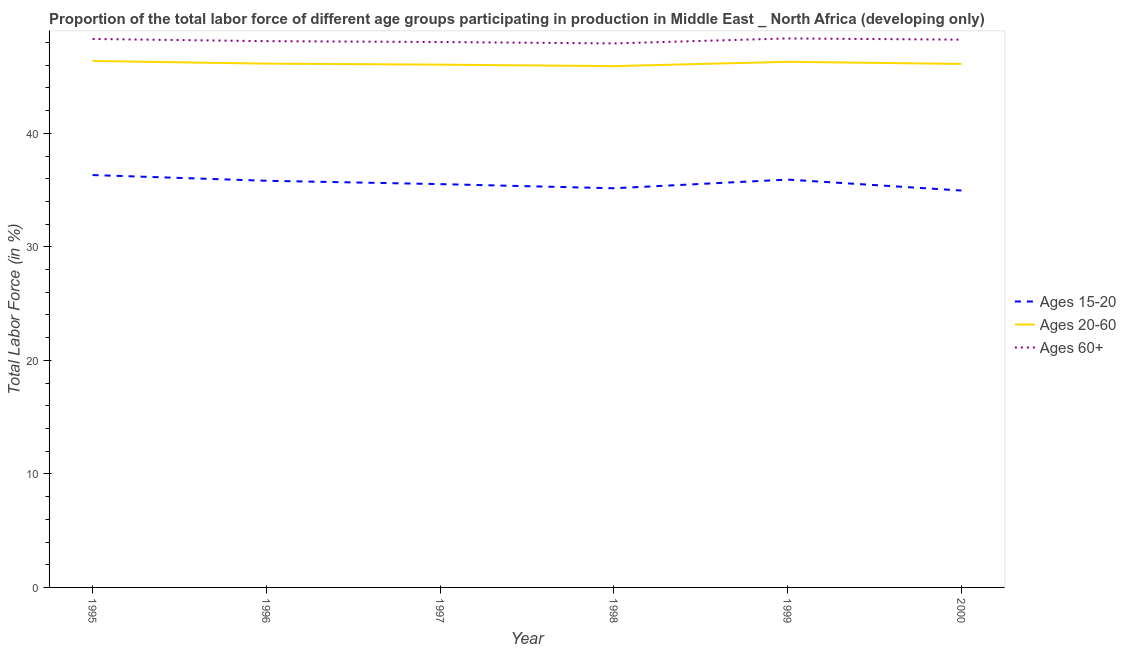Does the line corresponding to percentage of labor force within the age group 15-20 intersect with the line corresponding to percentage of labor force above age 60?
Keep it short and to the point. No. What is the percentage of labor force above age 60 in 1999?
Provide a succinct answer. 48.36. Across all years, what is the maximum percentage of labor force above age 60?
Give a very brief answer. 48.36. Across all years, what is the minimum percentage of labor force within the age group 15-20?
Make the answer very short. 34.96. In which year was the percentage of labor force above age 60 maximum?
Your response must be concise. 1999. What is the total percentage of labor force within the age group 20-60 in the graph?
Offer a terse response. 276.88. What is the difference between the percentage of labor force within the age group 20-60 in 1996 and that in 1999?
Provide a short and direct response. -0.16. What is the difference between the percentage of labor force within the age group 20-60 in 1997 and the percentage of labor force within the age group 15-20 in 1996?
Offer a very short reply. 10.23. What is the average percentage of labor force above age 60 per year?
Your answer should be compact. 48.17. In the year 1996, what is the difference between the percentage of labor force within the age group 20-60 and percentage of labor force within the age group 15-20?
Keep it short and to the point. 10.32. In how many years, is the percentage of labor force within the age group 20-60 greater than 4 %?
Make the answer very short. 6. What is the ratio of the percentage of labor force within the age group 15-20 in 1995 to that in 1998?
Your answer should be compact. 1.03. Is the percentage of labor force above age 60 in 1997 less than that in 2000?
Your answer should be very brief. Yes. Is the difference between the percentage of labor force within the age group 20-60 in 1997 and 1998 greater than the difference between the percentage of labor force above age 60 in 1997 and 1998?
Offer a very short reply. Yes. What is the difference between the highest and the second highest percentage of labor force above age 60?
Give a very brief answer. 0.05. What is the difference between the highest and the lowest percentage of labor force within the age group 15-20?
Your answer should be compact. 1.36. Is the sum of the percentage of labor force within the age group 20-60 in 1998 and 1999 greater than the maximum percentage of labor force above age 60 across all years?
Give a very brief answer. Yes. Is it the case that in every year, the sum of the percentage of labor force within the age group 15-20 and percentage of labor force within the age group 20-60 is greater than the percentage of labor force above age 60?
Your answer should be compact. Yes. Does the percentage of labor force above age 60 monotonically increase over the years?
Your answer should be compact. No. How many years are there in the graph?
Your answer should be compact. 6. What is the difference between two consecutive major ticks on the Y-axis?
Give a very brief answer. 10. Does the graph contain any zero values?
Provide a short and direct response. No. How many legend labels are there?
Ensure brevity in your answer.  3. How are the legend labels stacked?
Your answer should be very brief. Vertical. What is the title of the graph?
Your response must be concise. Proportion of the total labor force of different age groups participating in production in Middle East _ North Africa (developing only). Does "Poland" appear as one of the legend labels in the graph?
Make the answer very short. No. What is the Total Labor Force (in %) in Ages 15-20 in 1995?
Give a very brief answer. 36.32. What is the Total Labor Force (in %) of Ages 20-60 in 1995?
Your response must be concise. 46.37. What is the Total Labor Force (in %) in Ages 60+ in 1995?
Offer a very short reply. 48.31. What is the Total Labor Force (in %) of Ages 15-20 in 1996?
Give a very brief answer. 35.82. What is the Total Labor Force (in %) in Ages 20-60 in 1996?
Keep it short and to the point. 46.14. What is the Total Labor Force (in %) in Ages 60+ in 1996?
Provide a short and direct response. 48.12. What is the Total Labor Force (in %) of Ages 15-20 in 1997?
Offer a very short reply. 35.52. What is the Total Labor Force (in %) in Ages 20-60 in 1997?
Offer a terse response. 46.05. What is the Total Labor Force (in %) in Ages 60+ in 1997?
Provide a short and direct response. 48.04. What is the Total Labor Force (in %) in Ages 15-20 in 1998?
Provide a short and direct response. 35.16. What is the Total Labor Force (in %) of Ages 20-60 in 1998?
Offer a very short reply. 45.92. What is the Total Labor Force (in %) in Ages 60+ in 1998?
Your answer should be very brief. 47.92. What is the Total Labor Force (in %) of Ages 15-20 in 1999?
Offer a terse response. 35.92. What is the Total Labor Force (in %) of Ages 20-60 in 1999?
Make the answer very short. 46.3. What is the Total Labor Force (in %) of Ages 60+ in 1999?
Offer a very short reply. 48.36. What is the Total Labor Force (in %) in Ages 15-20 in 2000?
Offer a very short reply. 34.96. What is the Total Labor Force (in %) of Ages 20-60 in 2000?
Your answer should be compact. 46.11. What is the Total Labor Force (in %) of Ages 60+ in 2000?
Give a very brief answer. 48.25. Across all years, what is the maximum Total Labor Force (in %) in Ages 15-20?
Your answer should be compact. 36.32. Across all years, what is the maximum Total Labor Force (in %) of Ages 20-60?
Provide a short and direct response. 46.37. Across all years, what is the maximum Total Labor Force (in %) of Ages 60+?
Give a very brief answer. 48.36. Across all years, what is the minimum Total Labor Force (in %) of Ages 15-20?
Your answer should be compact. 34.96. Across all years, what is the minimum Total Labor Force (in %) of Ages 20-60?
Keep it short and to the point. 45.92. Across all years, what is the minimum Total Labor Force (in %) of Ages 60+?
Provide a short and direct response. 47.92. What is the total Total Labor Force (in %) in Ages 15-20 in the graph?
Offer a very short reply. 213.71. What is the total Total Labor Force (in %) in Ages 20-60 in the graph?
Offer a very short reply. 276.88. What is the total Total Labor Force (in %) of Ages 60+ in the graph?
Give a very brief answer. 288.99. What is the difference between the Total Labor Force (in %) in Ages 15-20 in 1995 and that in 1996?
Your answer should be very brief. 0.5. What is the difference between the Total Labor Force (in %) of Ages 20-60 in 1995 and that in 1996?
Ensure brevity in your answer.  0.23. What is the difference between the Total Labor Force (in %) of Ages 60+ in 1995 and that in 1996?
Give a very brief answer. 0.19. What is the difference between the Total Labor Force (in %) in Ages 15-20 in 1995 and that in 1997?
Your answer should be very brief. 0.8. What is the difference between the Total Labor Force (in %) in Ages 20-60 in 1995 and that in 1997?
Your response must be concise. 0.32. What is the difference between the Total Labor Force (in %) of Ages 60+ in 1995 and that in 1997?
Give a very brief answer. 0.27. What is the difference between the Total Labor Force (in %) of Ages 15-20 in 1995 and that in 1998?
Your answer should be compact. 1.16. What is the difference between the Total Labor Force (in %) in Ages 20-60 in 1995 and that in 1998?
Offer a terse response. 0.45. What is the difference between the Total Labor Force (in %) in Ages 60+ in 1995 and that in 1998?
Ensure brevity in your answer.  0.39. What is the difference between the Total Labor Force (in %) of Ages 15-20 in 1995 and that in 1999?
Offer a terse response. 0.4. What is the difference between the Total Labor Force (in %) of Ages 20-60 in 1995 and that in 1999?
Your response must be concise. 0.07. What is the difference between the Total Labor Force (in %) in Ages 60+ in 1995 and that in 1999?
Your answer should be very brief. -0.05. What is the difference between the Total Labor Force (in %) in Ages 15-20 in 1995 and that in 2000?
Offer a terse response. 1.36. What is the difference between the Total Labor Force (in %) of Ages 20-60 in 1995 and that in 2000?
Give a very brief answer. 0.26. What is the difference between the Total Labor Force (in %) of Ages 60+ in 1995 and that in 2000?
Your answer should be very brief. 0.06. What is the difference between the Total Labor Force (in %) of Ages 15-20 in 1996 and that in 1997?
Give a very brief answer. 0.3. What is the difference between the Total Labor Force (in %) of Ages 20-60 in 1996 and that in 1997?
Ensure brevity in your answer.  0.09. What is the difference between the Total Labor Force (in %) of Ages 60+ in 1996 and that in 1997?
Offer a terse response. 0.08. What is the difference between the Total Labor Force (in %) in Ages 15-20 in 1996 and that in 1998?
Give a very brief answer. 0.66. What is the difference between the Total Labor Force (in %) of Ages 20-60 in 1996 and that in 1998?
Your answer should be compact. 0.22. What is the difference between the Total Labor Force (in %) of Ages 60+ in 1996 and that in 1998?
Provide a succinct answer. 0.2. What is the difference between the Total Labor Force (in %) of Ages 15-20 in 1996 and that in 1999?
Make the answer very short. -0.1. What is the difference between the Total Labor Force (in %) of Ages 20-60 in 1996 and that in 1999?
Give a very brief answer. -0.16. What is the difference between the Total Labor Force (in %) of Ages 60+ in 1996 and that in 1999?
Your response must be concise. -0.24. What is the difference between the Total Labor Force (in %) in Ages 15-20 in 1996 and that in 2000?
Ensure brevity in your answer.  0.86. What is the difference between the Total Labor Force (in %) in Ages 20-60 in 1996 and that in 2000?
Provide a succinct answer. 0.03. What is the difference between the Total Labor Force (in %) in Ages 60+ in 1996 and that in 2000?
Offer a very short reply. -0.13. What is the difference between the Total Labor Force (in %) of Ages 15-20 in 1997 and that in 1998?
Give a very brief answer. 0.37. What is the difference between the Total Labor Force (in %) in Ages 20-60 in 1997 and that in 1998?
Provide a short and direct response. 0.13. What is the difference between the Total Labor Force (in %) of Ages 60+ in 1997 and that in 1998?
Provide a short and direct response. 0.12. What is the difference between the Total Labor Force (in %) of Ages 15-20 in 1997 and that in 1999?
Your answer should be compact. -0.4. What is the difference between the Total Labor Force (in %) in Ages 20-60 in 1997 and that in 1999?
Give a very brief answer. -0.25. What is the difference between the Total Labor Force (in %) in Ages 60+ in 1997 and that in 1999?
Your answer should be very brief. -0.32. What is the difference between the Total Labor Force (in %) of Ages 15-20 in 1997 and that in 2000?
Your answer should be very brief. 0.57. What is the difference between the Total Labor Force (in %) in Ages 20-60 in 1997 and that in 2000?
Ensure brevity in your answer.  -0.07. What is the difference between the Total Labor Force (in %) in Ages 60+ in 1997 and that in 2000?
Give a very brief answer. -0.21. What is the difference between the Total Labor Force (in %) of Ages 15-20 in 1998 and that in 1999?
Your answer should be very brief. -0.76. What is the difference between the Total Labor Force (in %) in Ages 20-60 in 1998 and that in 1999?
Your answer should be very brief. -0.38. What is the difference between the Total Labor Force (in %) of Ages 60+ in 1998 and that in 1999?
Make the answer very short. -0.44. What is the difference between the Total Labor Force (in %) in Ages 15-20 in 1998 and that in 2000?
Make the answer very short. 0.2. What is the difference between the Total Labor Force (in %) of Ages 20-60 in 1998 and that in 2000?
Ensure brevity in your answer.  -0.19. What is the difference between the Total Labor Force (in %) of Ages 60+ in 1998 and that in 2000?
Make the answer very short. -0.33. What is the difference between the Total Labor Force (in %) in Ages 15-20 in 1999 and that in 2000?
Keep it short and to the point. 0.96. What is the difference between the Total Labor Force (in %) in Ages 20-60 in 1999 and that in 2000?
Give a very brief answer. 0.19. What is the difference between the Total Labor Force (in %) in Ages 60+ in 1999 and that in 2000?
Offer a terse response. 0.11. What is the difference between the Total Labor Force (in %) of Ages 15-20 in 1995 and the Total Labor Force (in %) of Ages 20-60 in 1996?
Provide a short and direct response. -9.81. What is the difference between the Total Labor Force (in %) of Ages 15-20 in 1995 and the Total Labor Force (in %) of Ages 60+ in 1996?
Keep it short and to the point. -11.79. What is the difference between the Total Labor Force (in %) of Ages 20-60 in 1995 and the Total Labor Force (in %) of Ages 60+ in 1996?
Offer a terse response. -1.75. What is the difference between the Total Labor Force (in %) in Ages 15-20 in 1995 and the Total Labor Force (in %) in Ages 20-60 in 1997?
Offer a terse response. -9.72. What is the difference between the Total Labor Force (in %) of Ages 15-20 in 1995 and the Total Labor Force (in %) of Ages 60+ in 1997?
Keep it short and to the point. -11.72. What is the difference between the Total Labor Force (in %) of Ages 20-60 in 1995 and the Total Labor Force (in %) of Ages 60+ in 1997?
Keep it short and to the point. -1.67. What is the difference between the Total Labor Force (in %) of Ages 15-20 in 1995 and the Total Labor Force (in %) of Ages 20-60 in 1998?
Make the answer very short. -9.6. What is the difference between the Total Labor Force (in %) in Ages 15-20 in 1995 and the Total Labor Force (in %) in Ages 60+ in 1998?
Keep it short and to the point. -11.59. What is the difference between the Total Labor Force (in %) in Ages 20-60 in 1995 and the Total Labor Force (in %) in Ages 60+ in 1998?
Your answer should be very brief. -1.55. What is the difference between the Total Labor Force (in %) of Ages 15-20 in 1995 and the Total Labor Force (in %) of Ages 20-60 in 1999?
Your answer should be very brief. -9.98. What is the difference between the Total Labor Force (in %) in Ages 15-20 in 1995 and the Total Labor Force (in %) in Ages 60+ in 1999?
Provide a short and direct response. -12.03. What is the difference between the Total Labor Force (in %) in Ages 20-60 in 1995 and the Total Labor Force (in %) in Ages 60+ in 1999?
Provide a short and direct response. -1.99. What is the difference between the Total Labor Force (in %) in Ages 15-20 in 1995 and the Total Labor Force (in %) in Ages 20-60 in 2000?
Offer a terse response. -9.79. What is the difference between the Total Labor Force (in %) in Ages 15-20 in 1995 and the Total Labor Force (in %) in Ages 60+ in 2000?
Your answer should be very brief. -11.93. What is the difference between the Total Labor Force (in %) of Ages 20-60 in 1995 and the Total Labor Force (in %) of Ages 60+ in 2000?
Offer a terse response. -1.88. What is the difference between the Total Labor Force (in %) of Ages 15-20 in 1996 and the Total Labor Force (in %) of Ages 20-60 in 1997?
Keep it short and to the point. -10.23. What is the difference between the Total Labor Force (in %) in Ages 15-20 in 1996 and the Total Labor Force (in %) in Ages 60+ in 1997?
Ensure brevity in your answer.  -12.22. What is the difference between the Total Labor Force (in %) of Ages 20-60 in 1996 and the Total Labor Force (in %) of Ages 60+ in 1997?
Provide a short and direct response. -1.9. What is the difference between the Total Labor Force (in %) in Ages 15-20 in 1996 and the Total Labor Force (in %) in Ages 20-60 in 1998?
Make the answer very short. -10.1. What is the difference between the Total Labor Force (in %) in Ages 15-20 in 1996 and the Total Labor Force (in %) in Ages 60+ in 1998?
Provide a succinct answer. -12.1. What is the difference between the Total Labor Force (in %) in Ages 20-60 in 1996 and the Total Labor Force (in %) in Ages 60+ in 1998?
Provide a succinct answer. -1.78. What is the difference between the Total Labor Force (in %) in Ages 15-20 in 1996 and the Total Labor Force (in %) in Ages 20-60 in 1999?
Your response must be concise. -10.48. What is the difference between the Total Labor Force (in %) of Ages 15-20 in 1996 and the Total Labor Force (in %) of Ages 60+ in 1999?
Your answer should be compact. -12.54. What is the difference between the Total Labor Force (in %) of Ages 20-60 in 1996 and the Total Labor Force (in %) of Ages 60+ in 1999?
Offer a terse response. -2.22. What is the difference between the Total Labor Force (in %) of Ages 15-20 in 1996 and the Total Labor Force (in %) of Ages 20-60 in 2000?
Offer a terse response. -10.29. What is the difference between the Total Labor Force (in %) in Ages 15-20 in 1996 and the Total Labor Force (in %) in Ages 60+ in 2000?
Provide a succinct answer. -12.43. What is the difference between the Total Labor Force (in %) of Ages 20-60 in 1996 and the Total Labor Force (in %) of Ages 60+ in 2000?
Provide a short and direct response. -2.11. What is the difference between the Total Labor Force (in %) of Ages 15-20 in 1997 and the Total Labor Force (in %) of Ages 20-60 in 1998?
Keep it short and to the point. -10.39. What is the difference between the Total Labor Force (in %) in Ages 15-20 in 1997 and the Total Labor Force (in %) in Ages 60+ in 1998?
Your answer should be very brief. -12.39. What is the difference between the Total Labor Force (in %) in Ages 20-60 in 1997 and the Total Labor Force (in %) in Ages 60+ in 1998?
Make the answer very short. -1.87. What is the difference between the Total Labor Force (in %) in Ages 15-20 in 1997 and the Total Labor Force (in %) in Ages 20-60 in 1999?
Ensure brevity in your answer.  -10.77. What is the difference between the Total Labor Force (in %) in Ages 15-20 in 1997 and the Total Labor Force (in %) in Ages 60+ in 1999?
Give a very brief answer. -12.83. What is the difference between the Total Labor Force (in %) of Ages 20-60 in 1997 and the Total Labor Force (in %) of Ages 60+ in 1999?
Offer a very short reply. -2.31. What is the difference between the Total Labor Force (in %) of Ages 15-20 in 1997 and the Total Labor Force (in %) of Ages 20-60 in 2000?
Provide a succinct answer. -10.59. What is the difference between the Total Labor Force (in %) in Ages 15-20 in 1997 and the Total Labor Force (in %) in Ages 60+ in 2000?
Keep it short and to the point. -12.73. What is the difference between the Total Labor Force (in %) in Ages 20-60 in 1997 and the Total Labor Force (in %) in Ages 60+ in 2000?
Your answer should be very brief. -2.2. What is the difference between the Total Labor Force (in %) of Ages 15-20 in 1998 and the Total Labor Force (in %) of Ages 20-60 in 1999?
Your answer should be compact. -11.14. What is the difference between the Total Labor Force (in %) of Ages 15-20 in 1998 and the Total Labor Force (in %) of Ages 60+ in 1999?
Your response must be concise. -13.2. What is the difference between the Total Labor Force (in %) of Ages 20-60 in 1998 and the Total Labor Force (in %) of Ages 60+ in 1999?
Your response must be concise. -2.44. What is the difference between the Total Labor Force (in %) of Ages 15-20 in 1998 and the Total Labor Force (in %) of Ages 20-60 in 2000?
Make the answer very short. -10.95. What is the difference between the Total Labor Force (in %) in Ages 15-20 in 1998 and the Total Labor Force (in %) in Ages 60+ in 2000?
Give a very brief answer. -13.09. What is the difference between the Total Labor Force (in %) of Ages 20-60 in 1998 and the Total Labor Force (in %) of Ages 60+ in 2000?
Ensure brevity in your answer.  -2.33. What is the difference between the Total Labor Force (in %) in Ages 15-20 in 1999 and the Total Labor Force (in %) in Ages 20-60 in 2000?
Your answer should be very brief. -10.19. What is the difference between the Total Labor Force (in %) in Ages 15-20 in 1999 and the Total Labor Force (in %) in Ages 60+ in 2000?
Your answer should be compact. -12.33. What is the difference between the Total Labor Force (in %) in Ages 20-60 in 1999 and the Total Labor Force (in %) in Ages 60+ in 2000?
Provide a short and direct response. -1.95. What is the average Total Labor Force (in %) of Ages 15-20 per year?
Your answer should be compact. 35.62. What is the average Total Labor Force (in %) of Ages 20-60 per year?
Offer a terse response. 46.15. What is the average Total Labor Force (in %) in Ages 60+ per year?
Offer a terse response. 48.16. In the year 1995, what is the difference between the Total Labor Force (in %) in Ages 15-20 and Total Labor Force (in %) in Ages 20-60?
Your answer should be very brief. -10.05. In the year 1995, what is the difference between the Total Labor Force (in %) of Ages 15-20 and Total Labor Force (in %) of Ages 60+?
Your answer should be compact. -11.99. In the year 1995, what is the difference between the Total Labor Force (in %) of Ages 20-60 and Total Labor Force (in %) of Ages 60+?
Ensure brevity in your answer.  -1.94. In the year 1996, what is the difference between the Total Labor Force (in %) in Ages 15-20 and Total Labor Force (in %) in Ages 20-60?
Your answer should be compact. -10.32. In the year 1996, what is the difference between the Total Labor Force (in %) of Ages 15-20 and Total Labor Force (in %) of Ages 60+?
Your answer should be very brief. -12.3. In the year 1996, what is the difference between the Total Labor Force (in %) of Ages 20-60 and Total Labor Force (in %) of Ages 60+?
Your answer should be very brief. -1.98. In the year 1997, what is the difference between the Total Labor Force (in %) of Ages 15-20 and Total Labor Force (in %) of Ages 20-60?
Make the answer very short. -10.52. In the year 1997, what is the difference between the Total Labor Force (in %) of Ages 15-20 and Total Labor Force (in %) of Ages 60+?
Your response must be concise. -12.52. In the year 1997, what is the difference between the Total Labor Force (in %) of Ages 20-60 and Total Labor Force (in %) of Ages 60+?
Give a very brief answer. -1.99. In the year 1998, what is the difference between the Total Labor Force (in %) of Ages 15-20 and Total Labor Force (in %) of Ages 20-60?
Provide a succinct answer. -10.76. In the year 1998, what is the difference between the Total Labor Force (in %) of Ages 15-20 and Total Labor Force (in %) of Ages 60+?
Provide a succinct answer. -12.76. In the year 1998, what is the difference between the Total Labor Force (in %) in Ages 20-60 and Total Labor Force (in %) in Ages 60+?
Your response must be concise. -2. In the year 1999, what is the difference between the Total Labor Force (in %) in Ages 15-20 and Total Labor Force (in %) in Ages 20-60?
Your answer should be compact. -10.38. In the year 1999, what is the difference between the Total Labor Force (in %) of Ages 15-20 and Total Labor Force (in %) of Ages 60+?
Give a very brief answer. -12.43. In the year 1999, what is the difference between the Total Labor Force (in %) in Ages 20-60 and Total Labor Force (in %) in Ages 60+?
Offer a terse response. -2.06. In the year 2000, what is the difference between the Total Labor Force (in %) of Ages 15-20 and Total Labor Force (in %) of Ages 20-60?
Give a very brief answer. -11.15. In the year 2000, what is the difference between the Total Labor Force (in %) in Ages 15-20 and Total Labor Force (in %) in Ages 60+?
Ensure brevity in your answer.  -13.29. In the year 2000, what is the difference between the Total Labor Force (in %) of Ages 20-60 and Total Labor Force (in %) of Ages 60+?
Give a very brief answer. -2.14. What is the ratio of the Total Labor Force (in %) of Ages 20-60 in 1995 to that in 1996?
Give a very brief answer. 1.01. What is the ratio of the Total Labor Force (in %) of Ages 15-20 in 1995 to that in 1997?
Your response must be concise. 1.02. What is the ratio of the Total Labor Force (in %) of Ages 60+ in 1995 to that in 1997?
Provide a succinct answer. 1.01. What is the ratio of the Total Labor Force (in %) of Ages 15-20 in 1995 to that in 1998?
Give a very brief answer. 1.03. What is the ratio of the Total Labor Force (in %) of Ages 20-60 in 1995 to that in 1998?
Keep it short and to the point. 1.01. What is the ratio of the Total Labor Force (in %) of Ages 60+ in 1995 to that in 1998?
Your answer should be very brief. 1.01. What is the ratio of the Total Labor Force (in %) of Ages 15-20 in 1995 to that in 1999?
Offer a very short reply. 1.01. What is the ratio of the Total Labor Force (in %) in Ages 20-60 in 1995 to that in 1999?
Make the answer very short. 1. What is the ratio of the Total Labor Force (in %) of Ages 60+ in 1995 to that in 1999?
Keep it short and to the point. 1. What is the ratio of the Total Labor Force (in %) of Ages 15-20 in 1995 to that in 2000?
Give a very brief answer. 1.04. What is the ratio of the Total Labor Force (in %) in Ages 20-60 in 1995 to that in 2000?
Provide a succinct answer. 1.01. What is the ratio of the Total Labor Force (in %) in Ages 15-20 in 1996 to that in 1997?
Your answer should be very brief. 1.01. What is the ratio of the Total Labor Force (in %) of Ages 15-20 in 1996 to that in 1998?
Provide a short and direct response. 1.02. What is the ratio of the Total Labor Force (in %) in Ages 15-20 in 1996 to that in 1999?
Keep it short and to the point. 1. What is the ratio of the Total Labor Force (in %) of Ages 20-60 in 1996 to that in 1999?
Offer a terse response. 1. What is the ratio of the Total Labor Force (in %) of Ages 60+ in 1996 to that in 1999?
Provide a short and direct response. 0.99. What is the ratio of the Total Labor Force (in %) of Ages 15-20 in 1996 to that in 2000?
Ensure brevity in your answer.  1.02. What is the ratio of the Total Labor Force (in %) in Ages 15-20 in 1997 to that in 1998?
Ensure brevity in your answer.  1.01. What is the ratio of the Total Labor Force (in %) in Ages 20-60 in 1997 to that in 1998?
Your response must be concise. 1. What is the ratio of the Total Labor Force (in %) of Ages 15-20 in 1997 to that in 1999?
Your answer should be very brief. 0.99. What is the ratio of the Total Labor Force (in %) in Ages 20-60 in 1997 to that in 1999?
Give a very brief answer. 0.99. What is the ratio of the Total Labor Force (in %) in Ages 60+ in 1997 to that in 1999?
Your answer should be very brief. 0.99. What is the ratio of the Total Labor Force (in %) of Ages 15-20 in 1997 to that in 2000?
Ensure brevity in your answer.  1.02. What is the ratio of the Total Labor Force (in %) in Ages 20-60 in 1997 to that in 2000?
Give a very brief answer. 1. What is the ratio of the Total Labor Force (in %) of Ages 15-20 in 1998 to that in 1999?
Your answer should be compact. 0.98. What is the ratio of the Total Labor Force (in %) in Ages 20-60 in 1998 to that in 1999?
Your response must be concise. 0.99. What is the ratio of the Total Labor Force (in %) in Ages 60+ in 1998 to that in 1999?
Your answer should be very brief. 0.99. What is the ratio of the Total Labor Force (in %) in Ages 15-20 in 1998 to that in 2000?
Provide a short and direct response. 1.01. What is the ratio of the Total Labor Force (in %) of Ages 15-20 in 1999 to that in 2000?
Provide a short and direct response. 1.03. What is the difference between the highest and the second highest Total Labor Force (in %) of Ages 15-20?
Your answer should be compact. 0.4. What is the difference between the highest and the second highest Total Labor Force (in %) of Ages 20-60?
Ensure brevity in your answer.  0.07. What is the difference between the highest and the second highest Total Labor Force (in %) in Ages 60+?
Keep it short and to the point. 0.05. What is the difference between the highest and the lowest Total Labor Force (in %) of Ages 15-20?
Your response must be concise. 1.36. What is the difference between the highest and the lowest Total Labor Force (in %) of Ages 20-60?
Your answer should be very brief. 0.45. What is the difference between the highest and the lowest Total Labor Force (in %) of Ages 60+?
Your answer should be very brief. 0.44. 